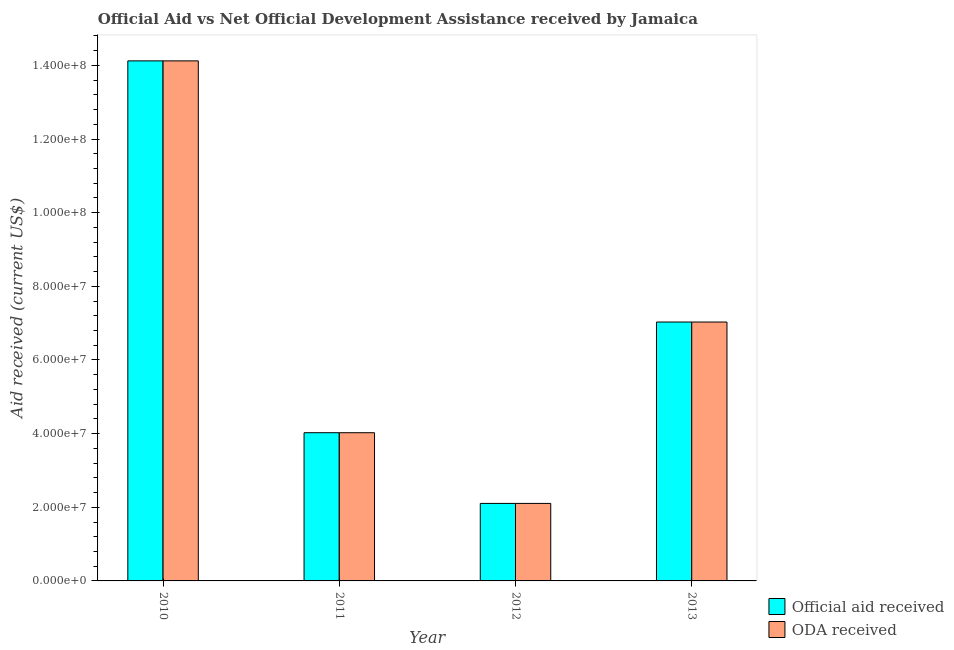How many different coloured bars are there?
Offer a very short reply. 2. How many groups of bars are there?
Your answer should be very brief. 4. Are the number of bars on each tick of the X-axis equal?
Make the answer very short. Yes. How many bars are there on the 2nd tick from the left?
Offer a terse response. 2. What is the label of the 1st group of bars from the left?
Keep it short and to the point. 2010. In how many cases, is the number of bars for a given year not equal to the number of legend labels?
Your response must be concise. 0. What is the oda received in 2013?
Provide a short and direct response. 7.03e+07. Across all years, what is the maximum oda received?
Your answer should be compact. 1.41e+08. Across all years, what is the minimum oda received?
Your answer should be compact. 2.10e+07. What is the total oda received in the graph?
Offer a terse response. 2.73e+08. What is the difference between the oda received in 2010 and that in 2011?
Give a very brief answer. 1.01e+08. What is the difference between the oda received in 2011 and the official aid received in 2010?
Provide a short and direct response. -1.01e+08. What is the average official aid received per year?
Your response must be concise. 6.82e+07. In the year 2012, what is the difference between the oda received and official aid received?
Your answer should be compact. 0. In how many years, is the official aid received greater than 4000000 US$?
Provide a short and direct response. 4. What is the ratio of the oda received in 2011 to that in 2013?
Provide a short and direct response. 0.57. Is the official aid received in 2010 less than that in 2012?
Offer a very short reply. No. What is the difference between the highest and the second highest oda received?
Offer a very short reply. 7.09e+07. What is the difference between the highest and the lowest oda received?
Ensure brevity in your answer.  1.20e+08. In how many years, is the oda received greater than the average oda received taken over all years?
Provide a short and direct response. 2. What does the 2nd bar from the left in 2012 represents?
Ensure brevity in your answer.  ODA received. What does the 1st bar from the right in 2013 represents?
Keep it short and to the point. ODA received. Are all the bars in the graph horizontal?
Provide a succinct answer. No. How many years are there in the graph?
Give a very brief answer. 4. What is the difference between two consecutive major ticks on the Y-axis?
Ensure brevity in your answer.  2.00e+07. Are the values on the major ticks of Y-axis written in scientific E-notation?
Keep it short and to the point. Yes. How many legend labels are there?
Make the answer very short. 2. How are the legend labels stacked?
Your response must be concise. Vertical. What is the title of the graph?
Your answer should be very brief. Official Aid vs Net Official Development Assistance received by Jamaica . Does "Number of departures" appear as one of the legend labels in the graph?
Your response must be concise. No. What is the label or title of the Y-axis?
Give a very brief answer. Aid received (current US$). What is the Aid received (current US$) of Official aid received in 2010?
Give a very brief answer. 1.41e+08. What is the Aid received (current US$) of ODA received in 2010?
Provide a succinct answer. 1.41e+08. What is the Aid received (current US$) in Official aid received in 2011?
Your response must be concise. 4.02e+07. What is the Aid received (current US$) of ODA received in 2011?
Your response must be concise. 4.02e+07. What is the Aid received (current US$) of Official aid received in 2012?
Provide a short and direct response. 2.10e+07. What is the Aid received (current US$) in ODA received in 2012?
Keep it short and to the point. 2.10e+07. What is the Aid received (current US$) in Official aid received in 2013?
Provide a succinct answer. 7.03e+07. What is the Aid received (current US$) of ODA received in 2013?
Keep it short and to the point. 7.03e+07. Across all years, what is the maximum Aid received (current US$) in Official aid received?
Your response must be concise. 1.41e+08. Across all years, what is the maximum Aid received (current US$) in ODA received?
Ensure brevity in your answer.  1.41e+08. Across all years, what is the minimum Aid received (current US$) of Official aid received?
Give a very brief answer. 2.10e+07. Across all years, what is the minimum Aid received (current US$) of ODA received?
Provide a short and direct response. 2.10e+07. What is the total Aid received (current US$) of Official aid received in the graph?
Make the answer very short. 2.73e+08. What is the total Aid received (current US$) of ODA received in the graph?
Make the answer very short. 2.73e+08. What is the difference between the Aid received (current US$) of Official aid received in 2010 and that in 2011?
Give a very brief answer. 1.01e+08. What is the difference between the Aid received (current US$) in ODA received in 2010 and that in 2011?
Offer a very short reply. 1.01e+08. What is the difference between the Aid received (current US$) in Official aid received in 2010 and that in 2012?
Provide a succinct answer. 1.20e+08. What is the difference between the Aid received (current US$) of ODA received in 2010 and that in 2012?
Provide a succinct answer. 1.20e+08. What is the difference between the Aid received (current US$) in Official aid received in 2010 and that in 2013?
Your answer should be very brief. 7.09e+07. What is the difference between the Aid received (current US$) of ODA received in 2010 and that in 2013?
Keep it short and to the point. 7.09e+07. What is the difference between the Aid received (current US$) in Official aid received in 2011 and that in 2012?
Your response must be concise. 1.92e+07. What is the difference between the Aid received (current US$) in ODA received in 2011 and that in 2012?
Offer a very short reply. 1.92e+07. What is the difference between the Aid received (current US$) in Official aid received in 2011 and that in 2013?
Your answer should be very brief. -3.01e+07. What is the difference between the Aid received (current US$) in ODA received in 2011 and that in 2013?
Your answer should be very brief. -3.01e+07. What is the difference between the Aid received (current US$) in Official aid received in 2012 and that in 2013?
Provide a short and direct response. -4.93e+07. What is the difference between the Aid received (current US$) in ODA received in 2012 and that in 2013?
Offer a terse response. -4.93e+07. What is the difference between the Aid received (current US$) in Official aid received in 2010 and the Aid received (current US$) in ODA received in 2011?
Give a very brief answer. 1.01e+08. What is the difference between the Aid received (current US$) of Official aid received in 2010 and the Aid received (current US$) of ODA received in 2012?
Offer a very short reply. 1.20e+08. What is the difference between the Aid received (current US$) in Official aid received in 2010 and the Aid received (current US$) in ODA received in 2013?
Make the answer very short. 7.09e+07. What is the difference between the Aid received (current US$) of Official aid received in 2011 and the Aid received (current US$) of ODA received in 2012?
Your answer should be very brief. 1.92e+07. What is the difference between the Aid received (current US$) in Official aid received in 2011 and the Aid received (current US$) in ODA received in 2013?
Give a very brief answer. -3.01e+07. What is the difference between the Aid received (current US$) of Official aid received in 2012 and the Aid received (current US$) of ODA received in 2013?
Your response must be concise. -4.93e+07. What is the average Aid received (current US$) of Official aid received per year?
Provide a succinct answer. 6.82e+07. What is the average Aid received (current US$) of ODA received per year?
Keep it short and to the point. 6.82e+07. In the year 2011, what is the difference between the Aid received (current US$) of Official aid received and Aid received (current US$) of ODA received?
Your answer should be compact. 0. In the year 2012, what is the difference between the Aid received (current US$) in Official aid received and Aid received (current US$) in ODA received?
Offer a terse response. 0. What is the ratio of the Aid received (current US$) of Official aid received in 2010 to that in 2011?
Offer a terse response. 3.51. What is the ratio of the Aid received (current US$) in ODA received in 2010 to that in 2011?
Your answer should be compact. 3.51. What is the ratio of the Aid received (current US$) in Official aid received in 2010 to that in 2012?
Your answer should be compact. 6.71. What is the ratio of the Aid received (current US$) in ODA received in 2010 to that in 2012?
Make the answer very short. 6.71. What is the ratio of the Aid received (current US$) in Official aid received in 2010 to that in 2013?
Keep it short and to the point. 2.01. What is the ratio of the Aid received (current US$) in ODA received in 2010 to that in 2013?
Give a very brief answer. 2.01. What is the ratio of the Aid received (current US$) in Official aid received in 2011 to that in 2012?
Give a very brief answer. 1.91. What is the ratio of the Aid received (current US$) of ODA received in 2011 to that in 2012?
Keep it short and to the point. 1.91. What is the ratio of the Aid received (current US$) of Official aid received in 2011 to that in 2013?
Offer a terse response. 0.57. What is the ratio of the Aid received (current US$) in ODA received in 2011 to that in 2013?
Make the answer very short. 0.57. What is the ratio of the Aid received (current US$) in Official aid received in 2012 to that in 2013?
Offer a very short reply. 0.3. What is the ratio of the Aid received (current US$) of ODA received in 2012 to that in 2013?
Offer a very short reply. 0.3. What is the difference between the highest and the second highest Aid received (current US$) in Official aid received?
Your answer should be compact. 7.09e+07. What is the difference between the highest and the second highest Aid received (current US$) of ODA received?
Your answer should be compact. 7.09e+07. What is the difference between the highest and the lowest Aid received (current US$) of Official aid received?
Give a very brief answer. 1.20e+08. What is the difference between the highest and the lowest Aid received (current US$) of ODA received?
Your response must be concise. 1.20e+08. 